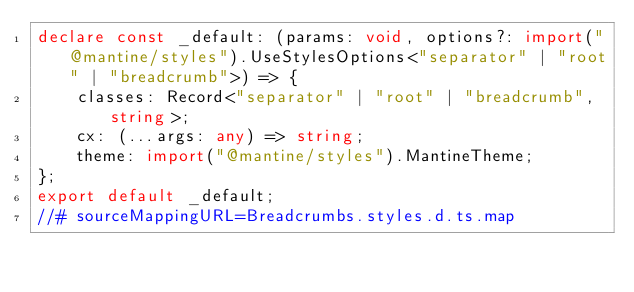Convert code to text. <code><loc_0><loc_0><loc_500><loc_500><_TypeScript_>declare const _default: (params: void, options?: import("@mantine/styles").UseStylesOptions<"separator" | "root" | "breadcrumb">) => {
    classes: Record<"separator" | "root" | "breadcrumb", string>;
    cx: (...args: any) => string;
    theme: import("@mantine/styles").MantineTheme;
};
export default _default;
//# sourceMappingURL=Breadcrumbs.styles.d.ts.map</code> 